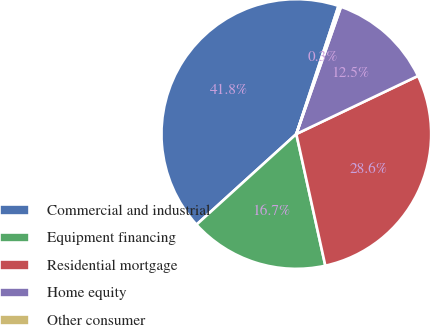<chart> <loc_0><loc_0><loc_500><loc_500><pie_chart><fcel>Commercial and industrial<fcel>Equipment financing<fcel>Residential mortgage<fcel>Home equity<fcel>Other consumer<nl><fcel>41.8%<fcel>16.72%<fcel>28.64%<fcel>12.54%<fcel>0.31%<nl></chart> 